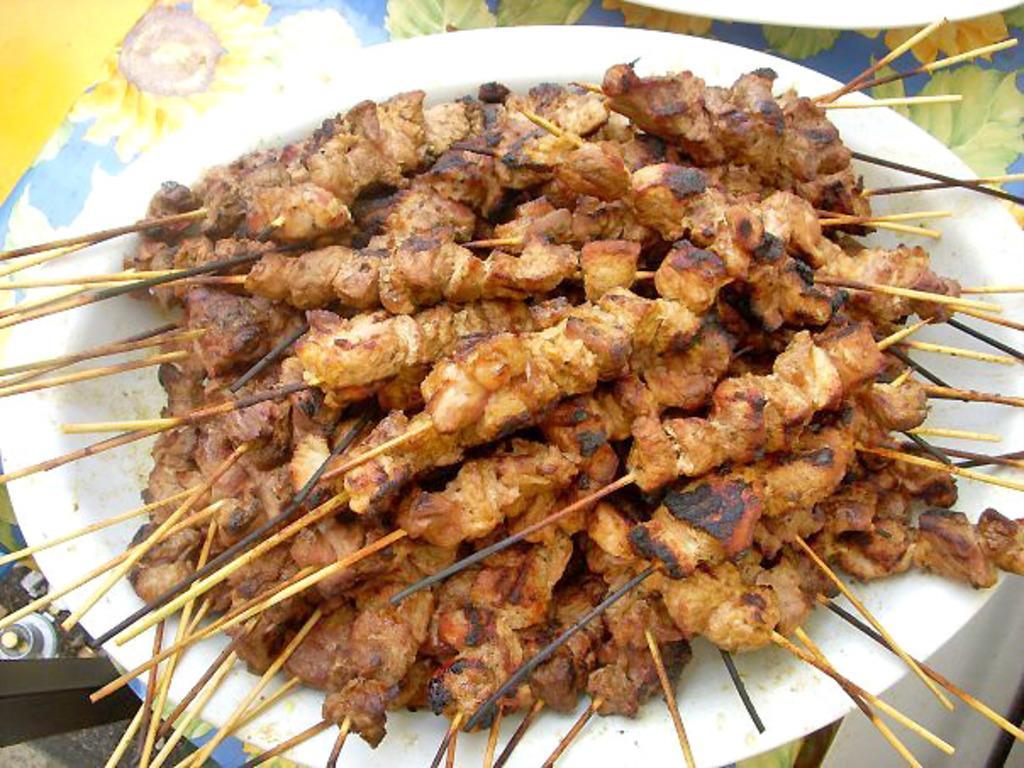Can you describe this image briefly? In this image we can see the grilled food with sticks and it is placed in the plate which is on the flowered mat. 